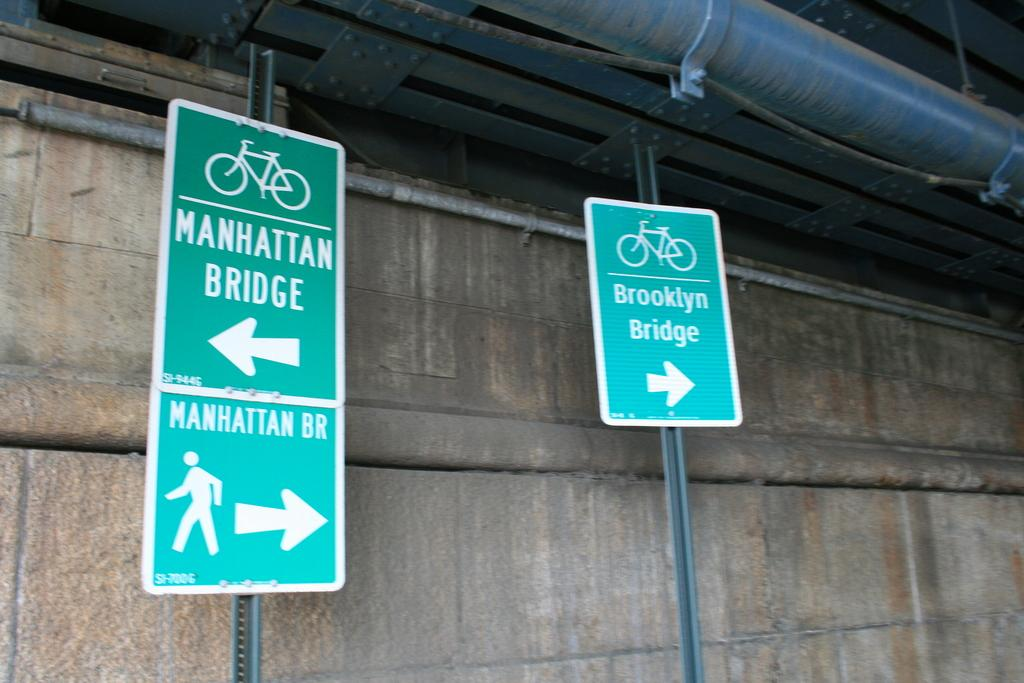<image>
Create a compact narrative representing the image presented. A green sign telling people which way to walk and bike across the Manhattan Bridge. 